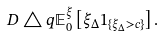<formula> <loc_0><loc_0><loc_500><loc_500>D \triangle q \mathbb { E } ^ { \xi } _ { 0 } \left [ \xi _ { \Delta } 1 _ { \{ \xi _ { \Delta } > c \} } \right ] .</formula> 